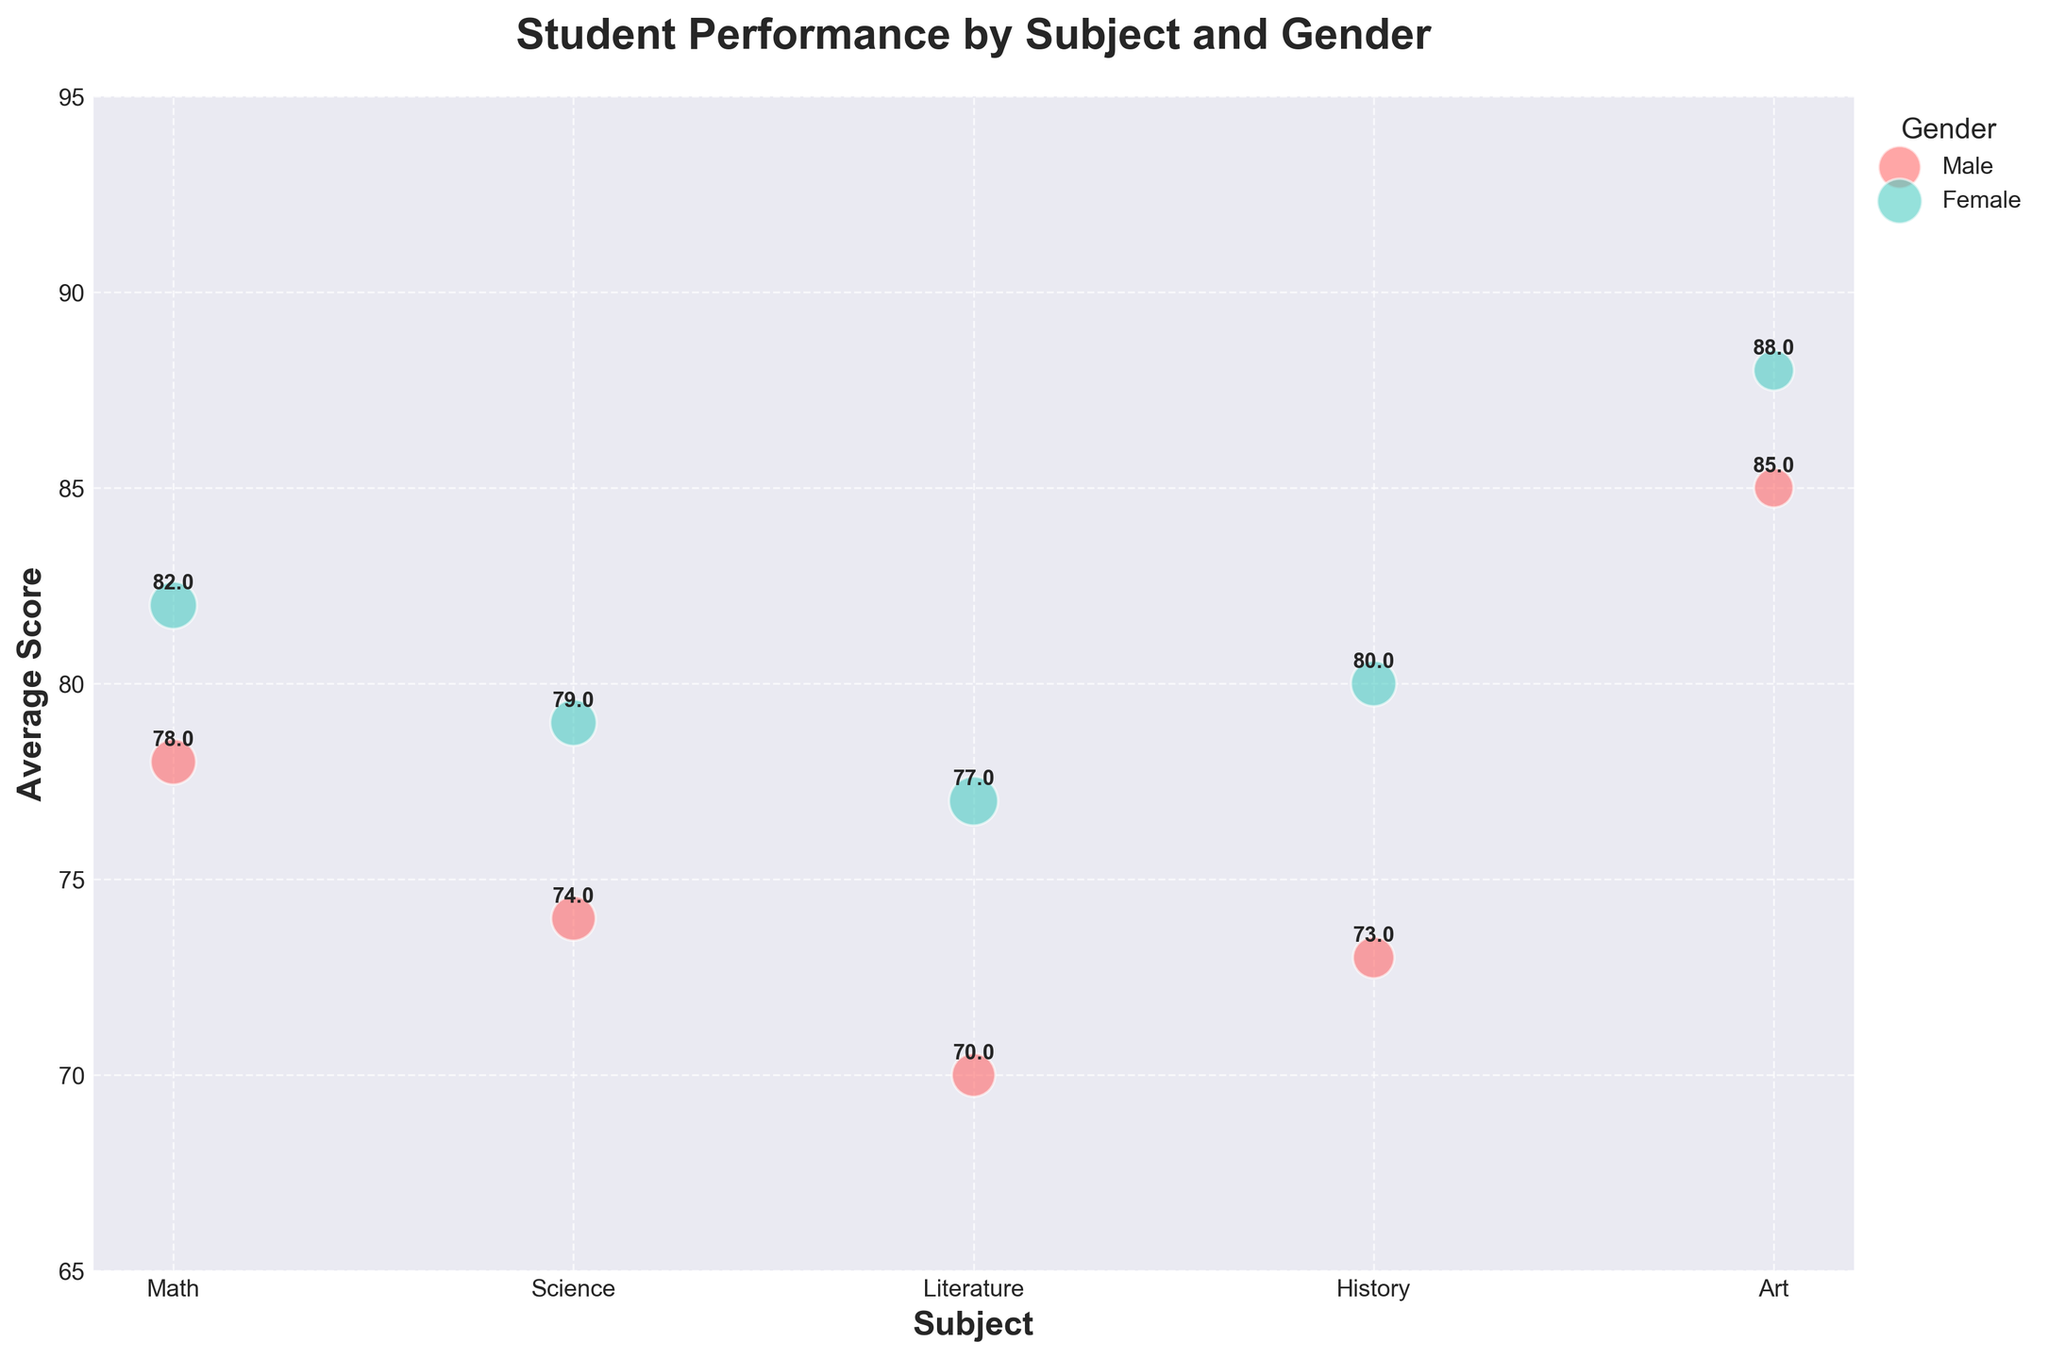What's the title of the bubble chart? The title is located at the top of the figure, clearly stating the subject of the chart.
Answer: Student Performance by Subject and Gender What are the axis labels on the chart? The x-axis label is "Subject," and the y-axis label is "Average Score," which are located next to respective axes.
Answer: Subject (x-axis), Average Score (y-axis) For which subject do male and female students have the smallest difference in average scores? By comparing the annotated average scores for each subject for both genders, the difference in Math is 4 (82 - 78), Science is 5 (79 - 74), Literature is 7 (77 - 70), History is 7 (80 - 73), and Art is 3 (88 - 85).
Answer: Art What gender has the highest average score in Science, and what is that score? By looking at the Science bubble annotations, the male average score is 74, and the female average score is 79.
Answer: Female, 79 How many students participated in Literature, summing both genders? Adding the student counts for males (110) and females (140) within the Literature subject bubble.
Answer: 250 In which subject do female students have an average score closest to the overall highest average score on the chart? The overall highest average score on the chart is 88 in Art. Checking the averages in other subjects for females, the next closest score is 82 in Math.
Answer: Math Which subject's bubble size, across both genders, is the largest in the chart? The size of the bubble is related to the number of students. Combining the student counts for each subject shows Literature (110+140=250) has the largest bubble.
Answer: Literature In which subjects do male students score lower than female students? Comparing average scores for both genders in all subjects:
Math (78 vs. 82), Science (74 vs. 79), Literature (70 vs. 77), History (73 vs. 80), Art (85 vs. 88), male scores are lower in all subjects.
Answer: All subjects For which subject do male and female students score the highest average, respectively? Looking for the highest annotated average scores: Female: Art (88) and Male: Art (85).
Answer: Art for both Which gender has more students in History, and what is the count? Checking the student counts in the History subject bubble shows males have 100 students, and females have 120.
Answer: Female, 120 